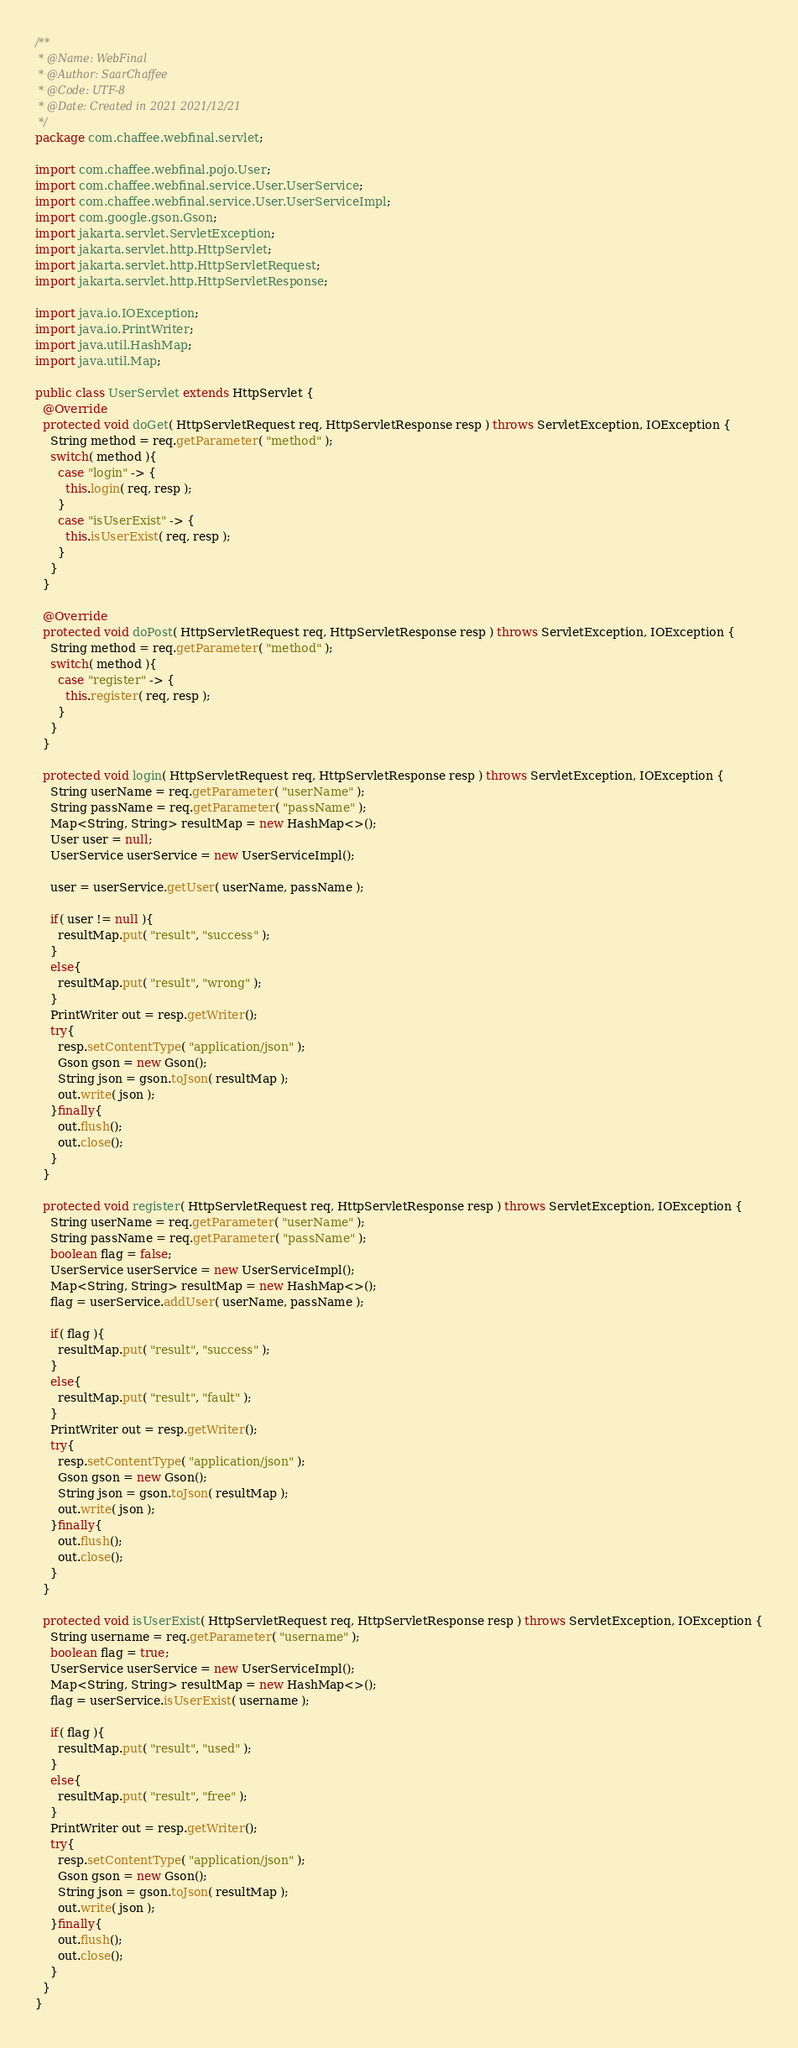<code> <loc_0><loc_0><loc_500><loc_500><_Java_>/**
 * @Name: WebFinal
 * @Author: SaarChaffee
 * @Code: UTF-8
 * @Date: Created in 2021 2021/12/21
 */
package com.chaffee.webfinal.servlet;

import com.chaffee.webfinal.pojo.User;
import com.chaffee.webfinal.service.User.UserService;
import com.chaffee.webfinal.service.User.UserServiceImpl;
import com.google.gson.Gson;
import jakarta.servlet.ServletException;
import jakarta.servlet.http.HttpServlet;
import jakarta.servlet.http.HttpServletRequest;
import jakarta.servlet.http.HttpServletResponse;

import java.io.IOException;
import java.io.PrintWriter;
import java.util.HashMap;
import java.util.Map;

public class UserServlet extends HttpServlet {
  @Override
  protected void doGet( HttpServletRequest req, HttpServletResponse resp ) throws ServletException, IOException {
    String method = req.getParameter( "method" );
    switch( method ){
      case "login" -> {
        this.login( req, resp );
      }
      case "isUserExist" -> {
        this.isUserExist( req, resp );
      }
    }
  }
  
  @Override
  protected void doPost( HttpServletRequest req, HttpServletResponse resp ) throws ServletException, IOException {
    String method = req.getParameter( "method" );
    switch( method ){
      case "register" -> {
        this.register( req, resp );
      }
    }
  }
  
  protected void login( HttpServletRequest req, HttpServletResponse resp ) throws ServletException, IOException {
    String userName = req.getParameter( "userName" );
    String passName = req.getParameter( "passName" );
    Map<String, String> resultMap = new HashMap<>();
    User user = null;
    UserService userService = new UserServiceImpl();
    
    user = userService.getUser( userName, passName );
    
    if( user != null ){
      resultMap.put( "result", "success" );
    }
    else{
      resultMap.put( "result", "wrong" );
    }
    PrintWriter out = resp.getWriter();
    try{
      resp.setContentType( "application/json" );
      Gson gson = new Gson();
      String json = gson.toJson( resultMap );
      out.write( json );
    }finally{
      out.flush();
      out.close();
    }
  }
  
  protected void register( HttpServletRequest req, HttpServletResponse resp ) throws ServletException, IOException {
    String userName = req.getParameter( "userName" );
    String passName = req.getParameter( "passName" );
    boolean flag = false;
    UserService userService = new UserServiceImpl();
    Map<String, String> resultMap = new HashMap<>();
    flag = userService.addUser( userName, passName );
    
    if( flag ){
      resultMap.put( "result", "success" );
    }
    else{
      resultMap.put( "result", "fault" );
    }
    PrintWriter out = resp.getWriter();
    try{
      resp.setContentType( "application/json" );
      Gson gson = new Gson();
      String json = gson.toJson( resultMap );
      out.write( json );
    }finally{
      out.flush();
      out.close();
    }
  }
  
  protected void isUserExist( HttpServletRequest req, HttpServletResponse resp ) throws ServletException, IOException {
    String username = req.getParameter( "username" );
    boolean flag = true;
    UserService userService = new UserServiceImpl();
    Map<String, String> resultMap = new HashMap<>();
    flag = userService.isUserExist( username );
    
    if( flag ){
      resultMap.put( "result", "used" );
    }
    else{
      resultMap.put( "result", "free" );
    }
    PrintWriter out = resp.getWriter();
    try{
      resp.setContentType( "application/json" );
      Gson gson = new Gson();
      String json = gson.toJson( resultMap );
      out.write( json );
    }finally{
      out.flush();
      out.close();
    }
  }
}
</code> 